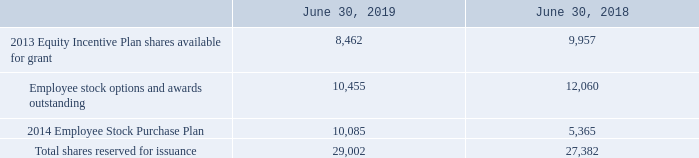Shares Reserved for Issuance
The following are shares reserved for issuance (in thousands):
Which years does the table provide information for the company's shares reserved for issuance? 2019, 2018. What was the amount of Employee stock options and awards outstanding in 2018?
Answer scale should be: thousand. 12,060. What was the amount of Total shares reserved for issuance in 2019?
Answer scale should be: thousand. 29,002. How many years did 2013 Equity Incentive Plan shares available for grant exceed $5,000 thousand? 2019##2018
Answer: 2. What was the change in the 2014 Employee Stock Purchase Plan between 2018 and 2019?
Answer scale should be: thousand. 10,085-5,365
Answer: 4720. What was the percentage change in the Total shares reserved for issuance between 2018 and 2019?
Answer scale should be: percent. (29,002-27,382)/27,382
Answer: 5.92. 